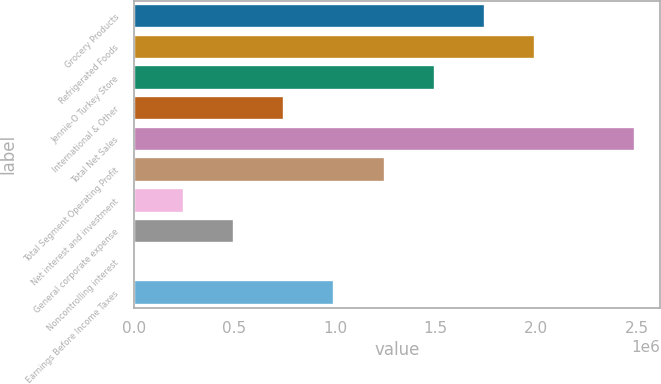Convert chart to OTSL. <chart><loc_0><loc_0><loc_500><loc_500><bar_chart><fcel>Grocery Products<fcel>Refrigerated Foods<fcel>Jennie-O Turkey Store<fcel>International & Other<fcel>Total Net Sales<fcel>Total Segment Operating Profit<fcel>Net interest and investment<fcel>General corporate expense<fcel>Noncontrolling interest<fcel>Earnings Before Income Taxes<nl><fcel>1.74489e+06<fcel>1.99413e+06<fcel>1.49565e+06<fcel>747929<fcel>2.49261e+06<fcel>1.24641e+06<fcel>249449<fcel>498689<fcel>209<fcel>997169<nl></chart> 